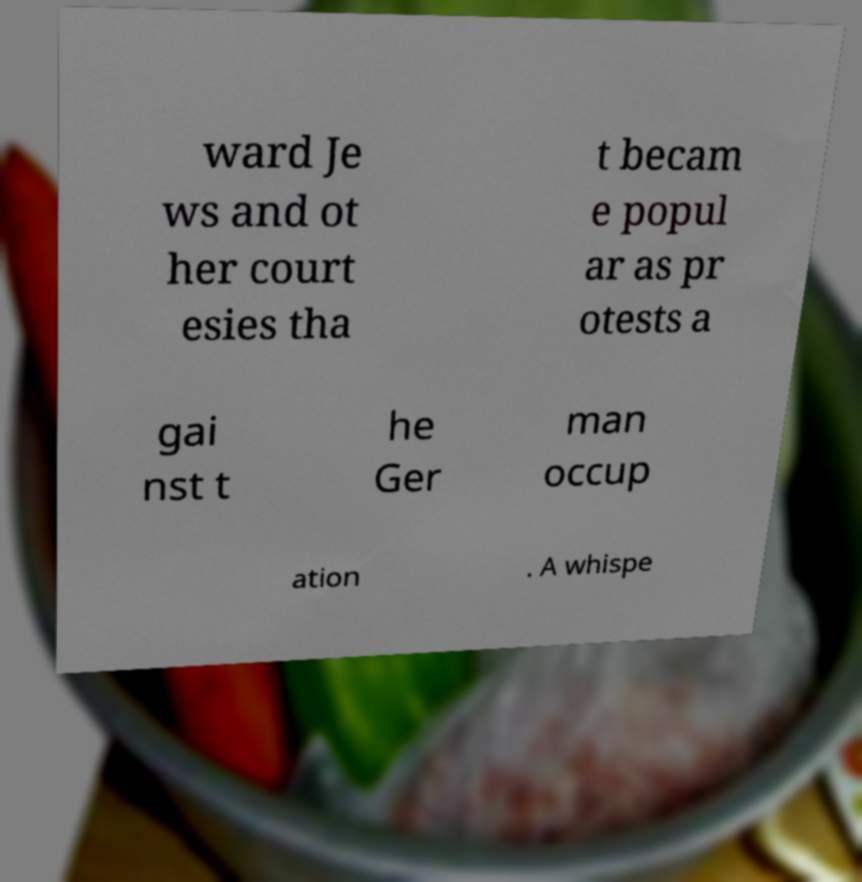For documentation purposes, I need the text within this image transcribed. Could you provide that? ward Je ws and ot her court esies tha t becam e popul ar as pr otests a gai nst t he Ger man occup ation . A whispe 